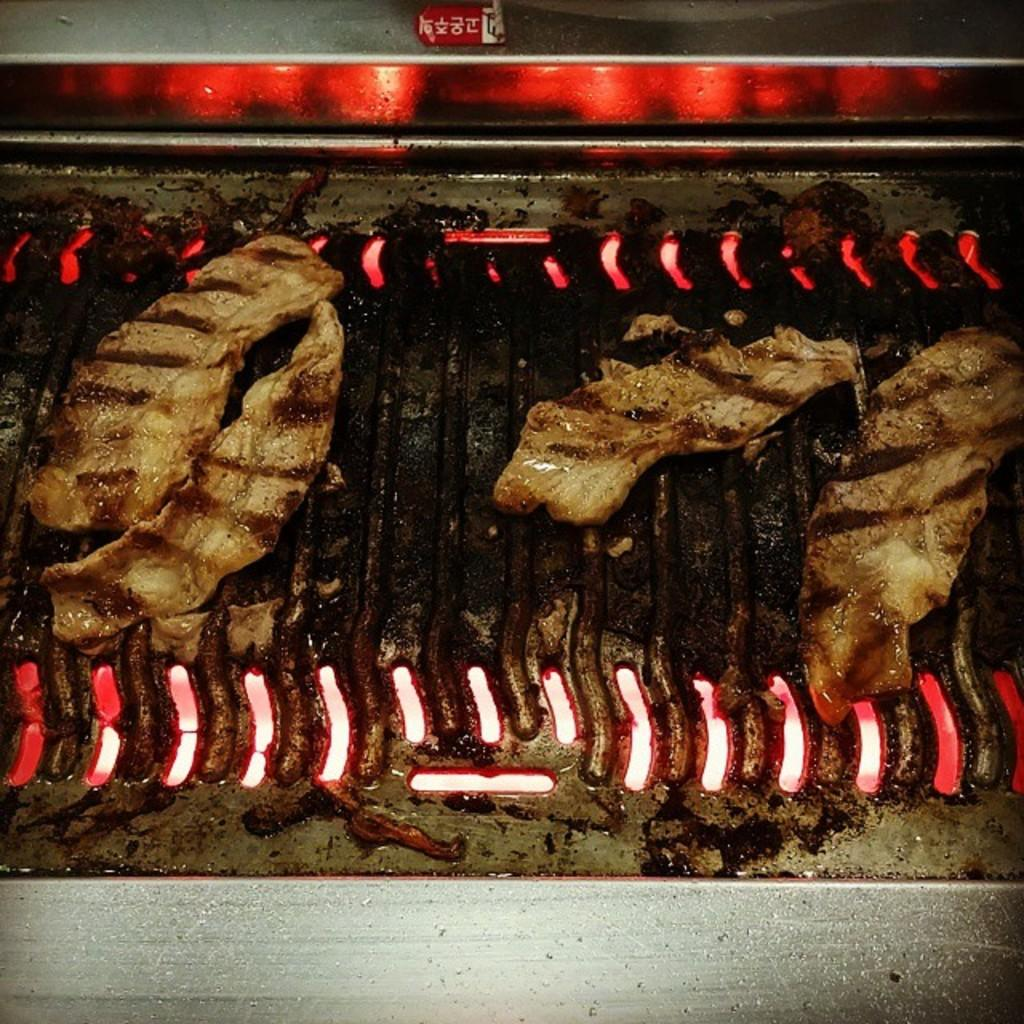What is being cooked on the charcoal in the image? There is food on the charcoal in the image. Where is the food located in relation to the image? The food is in the center of the image. What type of advertisement can be seen in the cemetery in the image? There is no cemetery or advertisement present in the image; it features food being cooked on charcoal. 